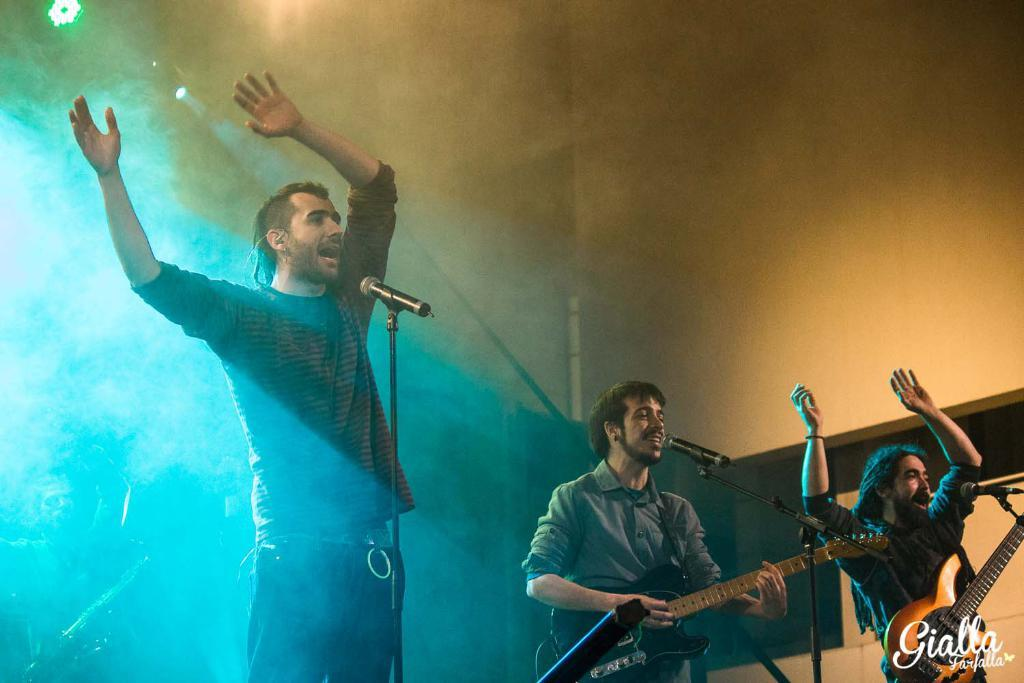How many men are present in the image? There are three men in the image. What are two of the men holding? Two of the men are holding guitars. What equipment is set up in front of the men? There are microphones in front of the men. What can be seen in the background of the image? There is a light and a wall in the background of the image. Where is the deer located in the image? There is no deer present in the image. What type of scene is depicted in the image? The image does not depict a specific scene; it shows three men with guitars and microphones. 